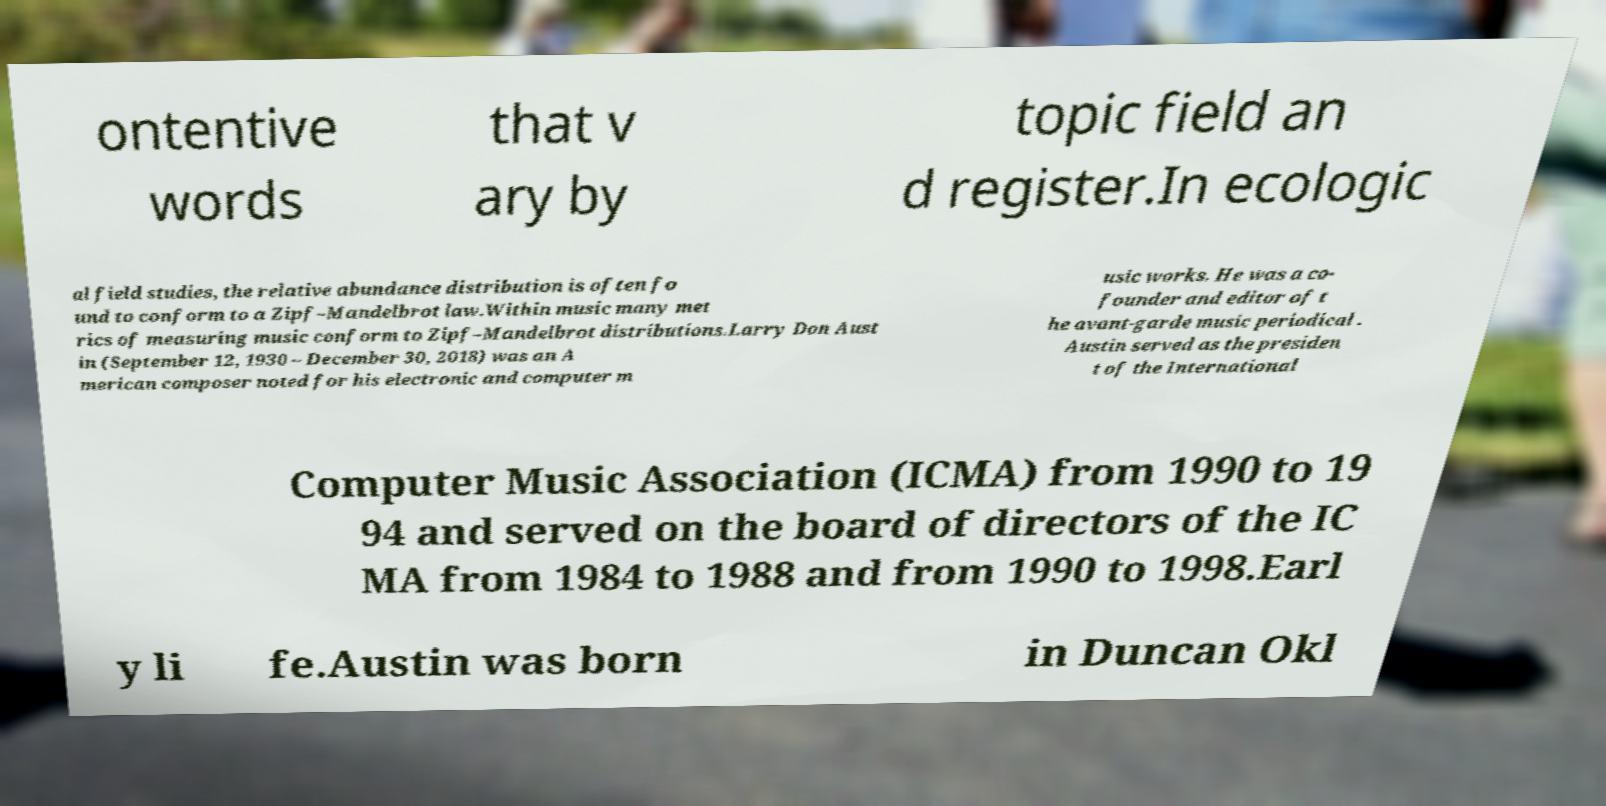Please identify and transcribe the text found in this image. ontentive words that v ary by topic field an d register.In ecologic al field studies, the relative abundance distribution is often fo und to conform to a Zipf–Mandelbrot law.Within music many met rics of measuring music conform to Zipf–Mandelbrot distributions.Larry Don Aust in (September 12, 1930 – December 30, 2018) was an A merican composer noted for his electronic and computer m usic works. He was a co- founder and editor of t he avant-garde music periodical . Austin served as the presiden t of the International Computer Music Association (ICMA) from 1990 to 19 94 and served on the board of directors of the IC MA from 1984 to 1988 and from 1990 to 1998.Earl y li fe.Austin was born in Duncan Okl 